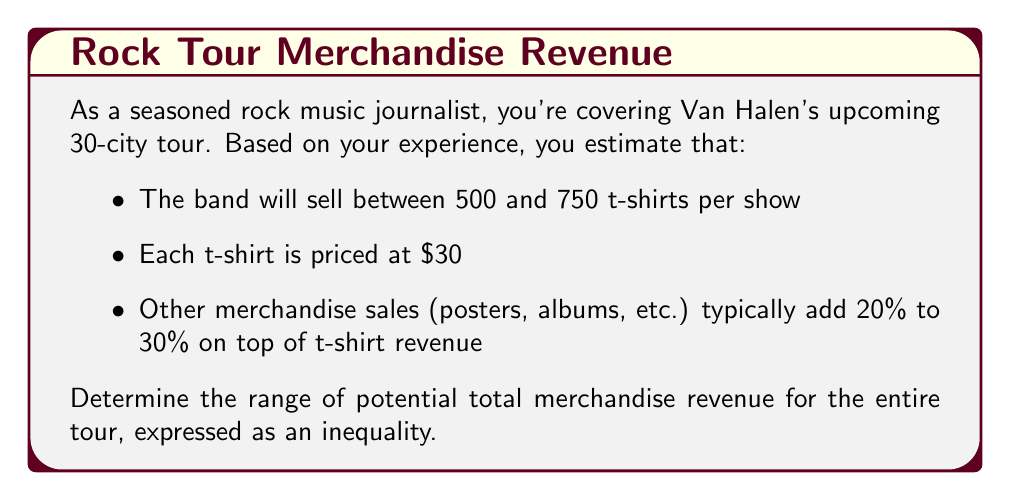Provide a solution to this math problem. Let's approach this step-by-step:

1) First, let's calculate the range of t-shirt sales per show:
   Minimum: $500 \times $30 = $15,000
   Maximum: $750 \times $30 = $22,500

2) Now, let's account for the entire 30-city tour:
   Minimum total t-shirt revenue: $15,000 \times 30 = $450,000
   Maximum total t-shirt revenue: $22,500 \times 30 = $675,000

3) Other merchandise adds 20% to 30% on top of t-shirt revenue:
   Minimum additional revenue: $450,000 \times 0.20 = $90,000
   Maximum additional revenue: $675,000 \times 0.30 = $202,500

4) Now, let's sum up the total potential revenue:
   Minimum total revenue: $450,000 + $90,000 = $540,000
   Maximum total revenue: $675,000 + $202,500 = $877,500

5) We can express this range as an inequality:

   $$540,000 \leq x \leq 877,500$$

   Where $x$ represents the total merchandise revenue for the tour.
Answer: $$540,000 \leq x \leq 877,500$$
Where $x$ represents the total merchandise revenue for the tour in dollars. 